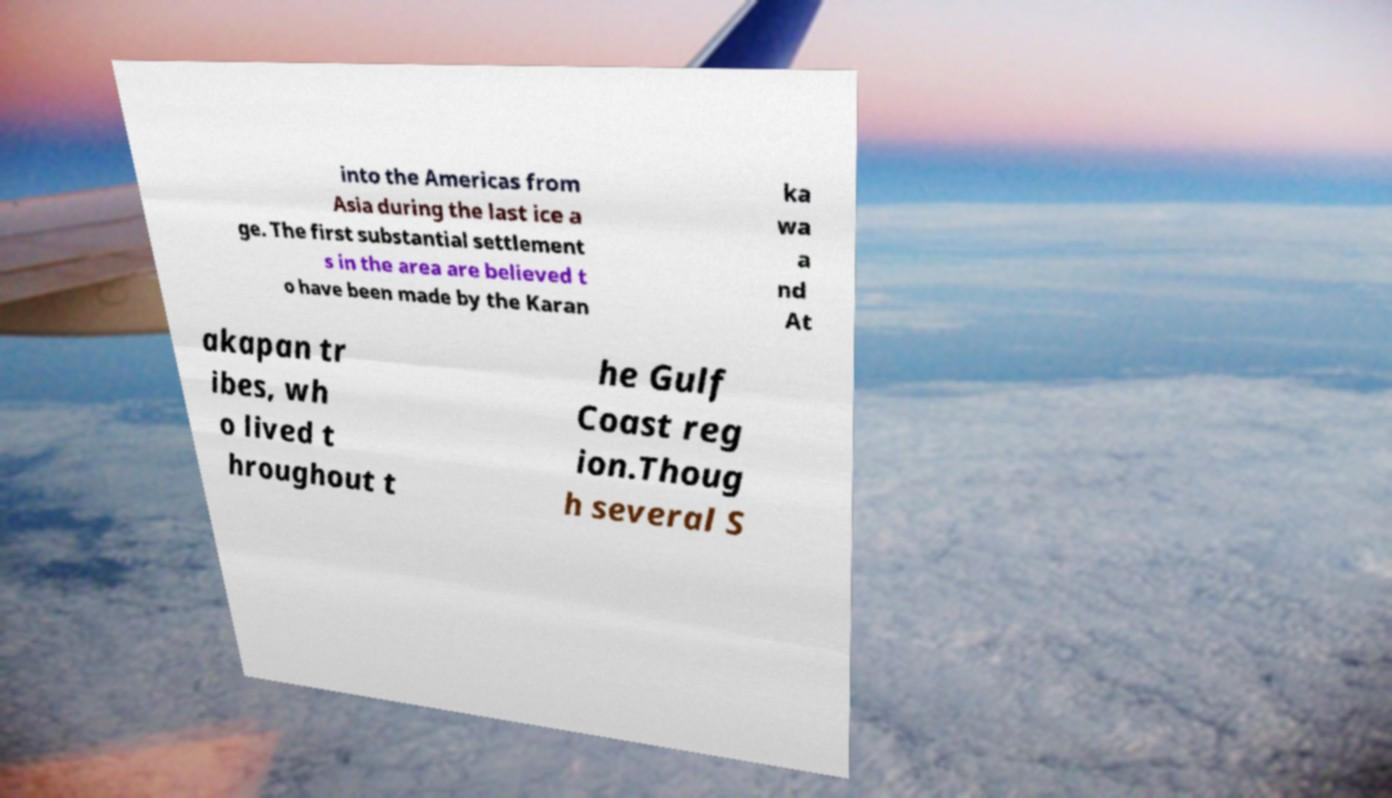Please read and relay the text visible in this image. What does it say? into the Americas from Asia during the last ice a ge. The first substantial settlement s in the area are believed t o have been made by the Karan ka wa a nd At akapan tr ibes, wh o lived t hroughout t he Gulf Coast reg ion.Thoug h several S 